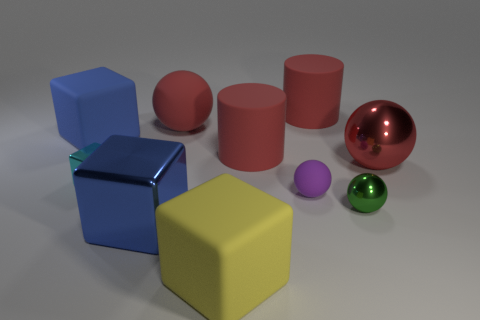Can you tell me something about the lighting in the image? The lighting in the image seems to come from above, casting soft shadows directly underneath the objects. This overhead lighting helps to accentuate the three-dimensionality of the shapes. 